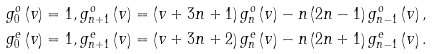<formula> <loc_0><loc_0><loc_500><loc_500>g _ { 0 } ^ { o } \left ( v \right ) & = 1 , g _ { n + 1 } ^ { o } \left ( v \right ) = \left ( v + 3 n + 1 \right ) g _ { n } ^ { o } \left ( v \right ) - n \left ( 2 n - 1 \right ) g _ { n - 1 } ^ { o } \left ( v \right ) , \\ g _ { 0 } ^ { e } \left ( v \right ) & = 1 , g _ { n + 1 } ^ { e } \left ( v \right ) = \left ( v + 3 n + 2 \right ) g _ { n } ^ { e } \left ( v \right ) - n \left ( 2 n + 1 \right ) g _ { n - 1 } ^ { e } \left ( v \right ) .</formula> 